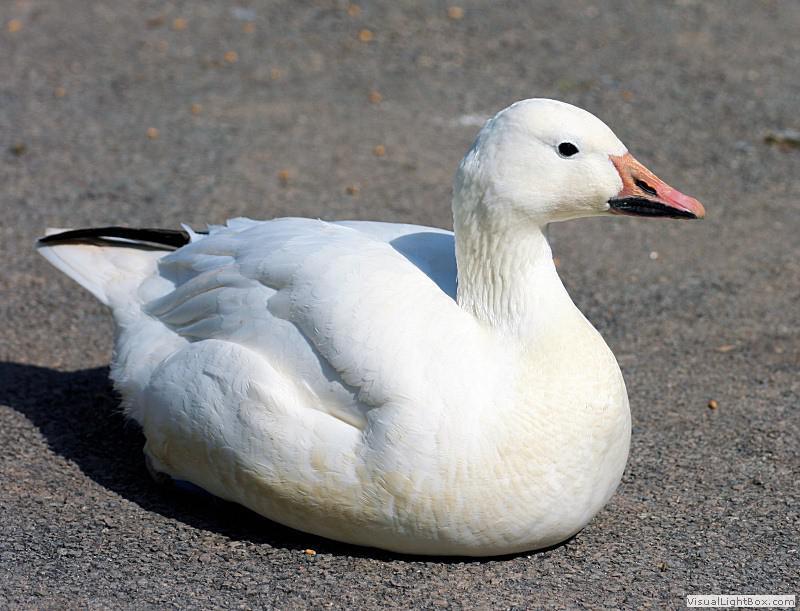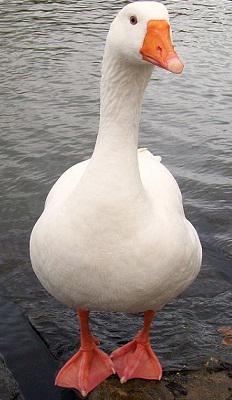The first image is the image on the left, the second image is the image on the right. Examine the images to the left and right. Is the description "In one of the images, a goose is flapping its wings while on the water" accurate? Answer yes or no. No. 